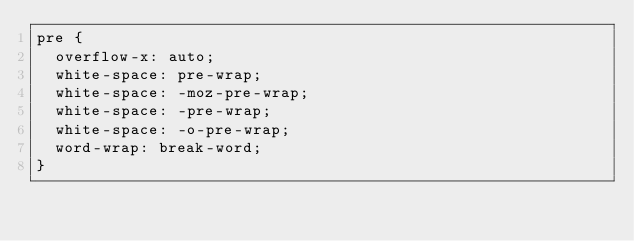Convert code to text. <code><loc_0><loc_0><loc_500><loc_500><_CSS_>pre {
  overflow-x: auto;
  white-space: pre-wrap;
  white-space: -moz-pre-wrap;
  white-space: -pre-wrap;
  white-space: -o-pre-wrap;
  word-wrap: break-word;
}
</code> 